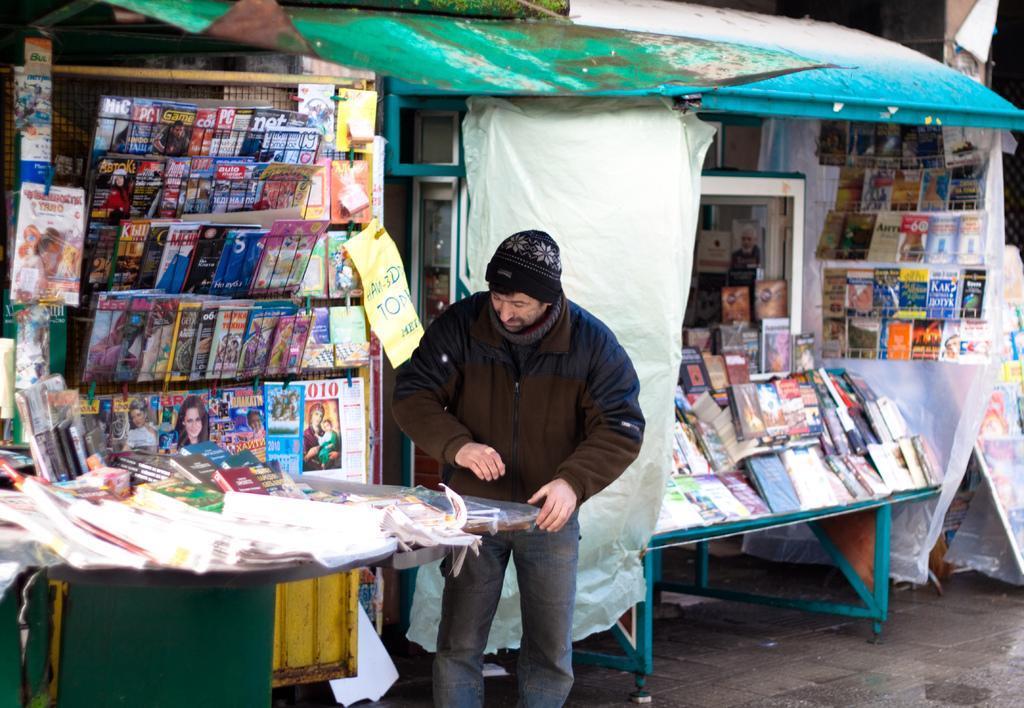Could you give a brief overview of what you see in this image? this picture shows a man standing and we see few books,magazines on the table 